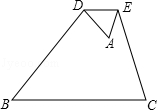If the area of triangle ABC is 64 square units, what is the area of triangle ADE? Given that triangle ABC has an area of 64 square units and the ratio of the area of triangle ADE to triangle ABC is 1/16, as previously discussed, the area of triangle ADE can be found by dividing the area of ABC by 16. Therefore, the area of ADE is 64/16, which equals 4 square units. 